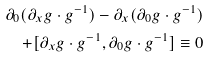<formula> <loc_0><loc_0><loc_500><loc_500>\partial _ { 0 } ( \partial _ { x } g \cdot g ^ { - 1 } ) - \partial _ { x } ( \partial _ { 0 } g \cdot g ^ { - 1 } ) \\ + [ \partial _ { x } g \cdot g ^ { - 1 } , \partial _ { 0 } g \cdot g ^ { - 1 } ] \equiv 0</formula> 